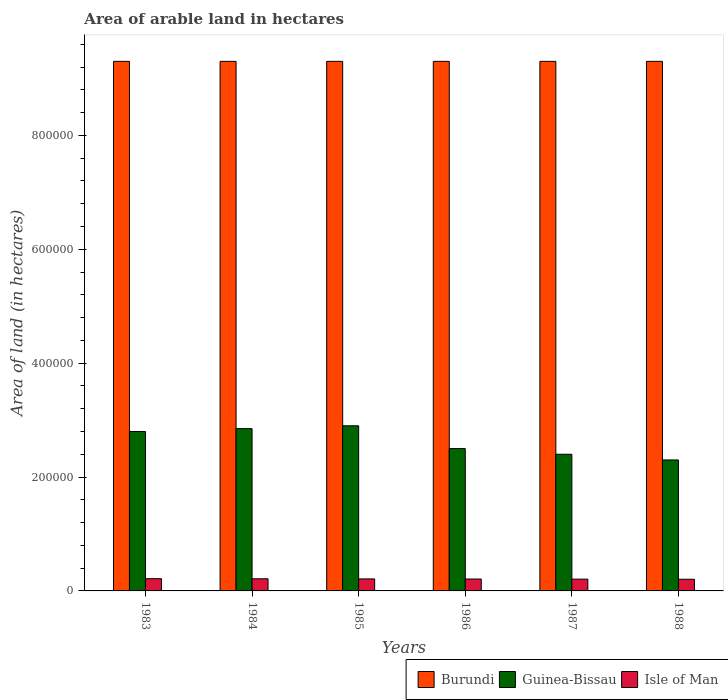How many groups of bars are there?
Provide a short and direct response. 6. Are the number of bars per tick equal to the number of legend labels?
Provide a short and direct response. Yes. Are the number of bars on each tick of the X-axis equal?
Provide a short and direct response. Yes. What is the label of the 1st group of bars from the left?
Provide a short and direct response. 1983. In how many cases, is the number of bars for a given year not equal to the number of legend labels?
Your answer should be compact. 0. What is the total arable land in Isle of Man in 1983?
Keep it short and to the point. 2.15e+04. Across all years, what is the maximum total arable land in Guinea-Bissau?
Give a very brief answer. 2.90e+05. Across all years, what is the minimum total arable land in Isle of Man?
Offer a terse response. 2.05e+04. In which year was the total arable land in Burundi maximum?
Your answer should be very brief. 1983. In which year was the total arable land in Guinea-Bissau minimum?
Provide a short and direct response. 1988. What is the total total arable land in Isle of Man in the graph?
Offer a very short reply. 1.26e+05. What is the difference between the total arable land in Guinea-Bissau in 1986 and that in 1987?
Provide a succinct answer. 10000. What is the difference between the total arable land in Guinea-Bissau in 1985 and the total arable land in Burundi in 1984?
Give a very brief answer. -6.40e+05. What is the average total arable land in Burundi per year?
Ensure brevity in your answer.  9.30e+05. In the year 1988, what is the difference between the total arable land in Isle of Man and total arable land in Guinea-Bissau?
Provide a succinct answer. -2.10e+05. What is the ratio of the total arable land in Guinea-Bissau in 1984 to that in 1986?
Ensure brevity in your answer.  1.14. Is the total arable land in Guinea-Bissau in 1983 less than that in 1984?
Your response must be concise. Yes. What is the difference between the highest and the second highest total arable land in Isle of Man?
Offer a terse response. 200. What is the difference between the highest and the lowest total arable land in Guinea-Bissau?
Provide a short and direct response. 6.00e+04. What does the 3rd bar from the left in 1983 represents?
Offer a very short reply. Isle of Man. What does the 1st bar from the right in 1983 represents?
Keep it short and to the point. Isle of Man. How many bars are there?
Make the answer very short. 18. Does the graph contain grids?
Keep it short and to the point. No. Where does the legend appear in the graph?
Make the answer very short. Bottom right. How many legend labels are there?
Ensure brevity in your answer.  3. How are the legend labels stacked?
Give a very brief answer. Horizontal. What is the title of the graph?
Ensure brevity in your answer.  Area of arable land in hectares. Does "Puerto Rico" appear as one of the legend labels in the graph?
Offer a very short reply. No. What is the label or title of the Y-axis?
Your answer should be very brief. Area of land (in hectares). What is the Area of land (in hectares) of Burundi in 1983?
Keep it short and to the point. 9.30e+05. What is the Area of land (in hectares) of Isle of Man in 1983?
Give a very brief answer. 2.15e+04. What is the Area of land (in hectares) in Burundi in 1984?
Make the answer very short. 9.30e+05. What is the Area of land (in hectares) of Guinea-Bissau in 1984?
Your answer should be very brief. 2.85e+05. What is the Area of land (in hectares) in Isle of Man in 1984?
Give a very brief answer. 2.13e+04. What is the Area of land (in hectares) in Burundi in 1985?
Ensure brevity in your answer.  9.30e+05. What is the Area of land (in hectares) in Isle of Man in 1985?
Ensure brevity in your answer.  2.11e+04. What is the Area of land (in hectares) in Burundi in 1986?
Offer a terse response. 9.30e+05. What is the Area of land (in hectares) of Guinea-Bissau in 1986?
Ensure brevity in your answer.  2.50e+05. What is the Area of land (in hectares) in Isle of Man in 1986?
Provide a succinct answer. 2.09e+04. What is the Area of land (in hectares) of Burundi in 1987?
Your response must be concise. 9.30e+05. What is the Area of land (in hectares) of Isle of Man in 1987?
Provide a succinct answer. 2.07e+04. What is the Area of land (in hectares) in Burundi in 1988?
Your answer should be compact. 9.30e+05. What is the Area of land (in hectares) in Isle of Man in 1988?
Offer a very short reply. 2.05e+04. Across all years, what is the maximum Area of land (in hectares) in Burundi?
Keep it short and to the point. 9.30e+05. Across all years, what is the maximum Area of land (in hectares) in Isle of Man?
Ensure brevity in your answer.  2.15e+04. Across all years, what is the minimum Area of land (in hectares) of Burundi?
Your answer should be compact. 9.30e+05. Across all years, what is the minimum Area of land (in hectares) of Isle of Man?
Provide a short and direct response. 2.05e+04. What is the total Area of land (in hectares) in Burundi in the graph?
Provide a succinct answer. 5.58e+06. What is the total Area of land (in hectares) in Guinea-Bissau in the graph?
Offer a very short reply. 1.58e+06. What is the total Area of land (in hectares) in Isle of Man in the graph?
Keep it short and to the point. 1.26e+05. What is the difference between the Area of land (in hectares) in Burundi in 1983 and that in 1984?
Give a very brief answer. 0. What is the difference between the Area of land (in hectares) of Guinea-Bissau in 1983 and that in 1984?
Provide a succinct answer. -5000. What is the difference between the Area of land (in hectares) in Isle of Man in 1983 and that in 1984?
Provide a succinct answer. 200. What is the difference between the Area of land (in hectares) of Burundi in 1983 and that in 1985?
Your response must be concise. 0. What is the difference between the Area of land (in hectares) of Isle of Man in 1983 and that in 1985?
Make the answer very short. 400. What is the difference between the Area of land (in hectares) in Burundi in 1983 and that in 1986?
Offer a terse response. 0. What is the difference between the Area of land (in hectares) of Guinea-Bissau in 1983 and that in 1986?
Offer a very short reply. 3.00e+04. What is the difference between the Area of land (in hectares) in Isle of Man in 1983 and that in 1986?
Provide a succinct answer. 600. What is the difference between the Area of land (in hectares) in Guinea-Bissau in 1983 and that in 1987?
Give a very brief answer. 4.00e+04. What is the difference between the Area of land (in hectares) in Isle of Man in 1983 and that in 1987?
Ensure brevity in your answer.  800. What is the difference between the Area of land (in hectares) of Guinea-Bissau in 1983 and that in 1988?
Keep it short and to the point. 5.00e+04. What is the difference between the Area of land (in hectares) in Guinea-Bissau in 1984 and that in 1985?
Your answer should be compact. -5000. What is the difference between the Area of land (in hectares) of Burundi in 1984 and that in 1986?
Your response must be concise. 0. What is the difference between the Area of land (in hectares) of Guinea-Bissau in 1984 and that in 1986?
Make the answer very short. 3.50e+04. What is the difference between the Area of land (in hectares) in Guinea-Bissau in 1984 and that in 1987?
Your answer should be compact. 4.50e+04. What is the difference between the Area of land (in hectares) in Isle of Man in 1984 and that in 1987?
Provide a succinct answer. 600. What is the difference between the Area of land (in hectares) of Guinea-Bissau in 1984 and that in 1988?
Your answer should be very brief. 5.50e+04. What is the difference between the Area of land (in hectares) in Isle of Man in 1984 and that in 1988?
Make the answer very short. 800. What is the difference between the Area of land (in hectares) of Burundi in 1985 and that in 1986?
Give a very brief answer. 0. What is the difference between the Area of land (in hectares) of Guinea-Bissau in 1985 and that in 1986?
Ensure brevity in your answer.  4.00e+04. What is the difference between the Area of land (in hectares) in Isle of Man in 1985 and that in 1986?
Your response must be concise. 200. What is the difference between the Area of land (in hectares) of Guinea-Bissau in 1985 and that in 1988?
Provide a succinct answer. 6.00e+04. What is the difference between the Area of land (in hectares) of Isle of Man in 1985 and that in 1988?
Your answer should be compact. 600. What is the difference between the Area of land (in hectares) in Burundi in 1986 and that in 1987?
Your answer should be compact. 0. What is the difference between the Area of land (in hectares) of Isle of Man in 1986 and that in 1987?
Offer a very short reply. 200. What is the difference between the Area of land (in hectares) of Burundi in 1986 and that in 1988?
Keep it short and to the point. 0. What is the difference between the Area of land (in hectares) of Isle of Man in 1986 and that in 1988?
Provide a short and direct response. 400. What is the difference between the Area of land (in hectares) of Burundi in 1983 and the Area of land (in hectares) of Guinea-Bissau in 1984?
Provide a succinct answer. 6.45e+05. What is the difference between the Area of land (in hectares) of Burundi in 1983 and the Area of land (in hectares) of Isle of Man in 1984?
Your answer should be very brief. 9.09e+05. What is the difference between the Area of land (in hectares) of Guinea-Bissau in 1983 and the Area of land (in hectares) of Isle of Man in 1984?
Make the answer very short. 2.59e+05. What is the difference between the Area of land (in hectares) of Burundi in 1983 and the Area of land (in hectares) of Guinea-Bissau in 1985?
Offer a terse response. 6.40e+05. What is the difference between the Area of land (in hectares) of Burundi in 1983 and the Area of land (in hectares) of Isle of Man in 1985?
Keep it short and to the point. 9.09e+05. What is the difference between the Area of land (in hectares) of Guinea-Bissau in 1983 and the Area of land (in hectares) of Isle of Man in 1985?
Provide a succinct answer. 2.59e+05. What is the difference between the Area of land (in hectares) of Burundi in 1983 and the Area of land (in hectares) of Guinea-Bissau in 1986?
Offer a terse response. 6.80e+05. What is the difference between the Area of land (in hectares) in Burundi in 1983 and the Area of land (in hectares) in Isle of Man in 1986?
Ensure brevity in your answer.  9.09e+05. What is the difference between the Area of land (in hectares) of Guinea-Bissau in 1983 and the Area of land (in hectares) of Isle of Man in 1986?
Provide a succinct answer. 2.59e+05. What is the difference between the Area of land (in hectares) of Burundi in 1983 and the Area of land (in hectares) of Guinea-Bissau in 1987?
Your response must be concise. 6.90e+05. What is the difference between the Area of land (in hectares) of Burundi in 1983 and the Area of land (in hectares) of Isle of Man in 1987?
Ensure brevity in your answer.  9.09e+05. What is the difference between the Area of land (in hectares) of Guinea-Bissau in 1983 and the Area of land (in hectares) of Isle of Man in 1987?
Keep it short and to the point. 2.59e+05. What is the difference between the Area of land (in hectares) of Burundi in 1983 and the Area of land (in hectares) of Isle of Man in 1988?
Offer a terse response. 9.10e+05. What is the difference between the Area of land (in hectares) in Guinea-Bissau in 1983 and the Area of land (in hectares) in Isle of Man in 1988?
Your answer should be compact. 2.60e+05. What is the difference between the Area of land (in hectares) of Burundi in 1984 and the Area of land (in hectares) of Guinea-Bissau in 1985?
Offer a terse response. 6.40e+05. What is the difference between the Area of land (in hectares) of Burundi in 1984 and the Area of land (in hectares) of Isle of Man in 1985?
Keep it short and to the point. 9.09e+05. What is the difference between the Area of land (in hectares) of Guinea-Bissau in 1984 and the Area of land (in hectares) of Isle of Man in 1985?
Ensure brevity in your answer.  2.64e+05. What is the difference between the Area of land (in hectares) of Burundi in 1984 and the Area of land (in hectares) of Guinea-Bissau in 1986?
Keep it short and to the point. 6.80e+05. What is the difference between the Area of land (in hectares) of Burundi in 1984 and the Area of land (in hectares) of Isle of Man in 1986?
Your answer should be very brief. 9.09e+05. What is the difference between the Area of land (in hectares) of Guinea-Bissau in 1984 and the Area of land (in hectares) of Isle of Man in 1986?
Provide a short and direct response. 2.64e+05. What is the difference between the Area of land (in hectares) of Burundi in 1984 and the Area of land (in hectares) of Guinea-Bissau in 1987?
Provide a short and direct response. 6.90e+05. What is the difference between the Area of land (in hectares) in Burundi in 1984 and the Area of land (in hectares) in Isle of Man in 1987?
Keep it short and to the point. 9.09e+05. What is the difference between the Area of land (in hectares) of Guinea-Bissau in 1984 and the Area of land (in hectares) of Isle of Man in 1987?
Offer a terse response. 2.64e+05. What is the difference between the Area of land (in hectares) of Burundi in 1984 and the Area of land (in hectares) of Guinea-Bissau in 1988?
Your answer should be very brief. 7.00e+05. What is the difference between the Area of land (in hectares) of Burundi in 1984 and the Area of land (in hectares) of Isle of Man in 1988?
Your answer should be compact. 9.10e+05. What is the difference between the Area of land (in hectares) of Guinea-Bissau in 1984 and the Area of land (in hectares) of Isle of Man in 1988?
Provide a succinct answer. 2.64e+05. What is the difference between the Area of land (in hectares) of Burundi in 1985 and the Area of land (in hectares) of Guinea-Bissau in 1986?
Offer a very short reply. 6.80e+05. What is the difference between the Area of land (in hectares) in Burundi in 1985 and the Area of land (in hectares) in Isle of Man in 1986?
Ensure brevity in your answer.  9.09e+05. What is the difference between the Area of land (in hectares) in Guinea-Bissau in 1985 and the Area of land (in hectares) in Isle of Man in 1986?
Offer a terse response. 2.69e+05. What is the difference between the Area of land (in hectares) of Burundi in 1985 and the Area of land (in hectares) of Guinea-Bissau in 1987?
Provide a succinct answer. 6.90e+05. What is the difference between the Area of land (in hectares) in Burundi in 1985 and the Area of land (in hectares) in Isle of Man in 1987?
Keep it short and to the point. 9.09e+05. What is the difference between the Area of land (in hectares) of Guinea-Bissau in 1985 and the Area of land (in hectares) of Isle of Man in 1987?
Ensure brevity in your answer.  2.69e+05. What is the difference between the Area of land (in hectares) of Burundi in 1985 and the Area of land (in hectares) of Guinea-Bissau in 1988?
Offer a very short reply. 7.00e+05. What is the difference between the Area of land (in hectares) of Burundi in 1985 and the Area of land (in hectares) of Isle of Man in 1988?
Provide a short and direct response. 9.10e+05. What is the difference between the Area of land (in hectares) in Guinea-Bissau in 1985 and the Area of land (in hectares) in Isle of Man in 1988?
Your answer should be very brief. 2.70e+05. What is the difference between the Area of land (in hectares) of Burundi in 1986 and the Area of land (in hectares) of Guinea-Bissau in 1987?
Give a very brief answer. 6.90e+05. What is the difference between the Area of land (in hectares) in Burundi in 1986 and the Area of land (in hectares) in Isle of Man in 1987?
Ensure brevity in your answer.  9.09e+05. What is the difference between the Area of land (in hectares) of Guinea-Bissau in 1986 and the Area of land (in hectares) of Isle of Man in 1987?
Your response must be concise. 2.29e+05. What is the difference between the Area of land (in hectares) in Burundi in 1986 and the Area of land (in hectares) in Guinea-Bissau in 1988?
Ensure brevity in your answer.  7.00e+05. What is the difference between the Area of land (in hectares) of Burundi in 1986 and the Area of land (in hectares) of Isle of Man in 1988?
Provide a short and direct response. 9.10e+05. What is the difference between the Area of land (in hectares) of Guinea-Bissau in 1986 and the Area of land (in hectares) of Isle of Man in 1988?
Your answer should be very brief. 2.30e+05. What is the difference between the Area of land (in hectares) in Burundi in 1987 and the Area of land (in hectares) in Guinea-Bissau in 1988?
Give a very brief answer. 7.00e+05. What is the difference between the Area of land (in hectares) in Burundi in 1987 and the Area of land (in hectares) in Isle of Man in 1988?
Keep it short and to the point. 9.10e+05. What is the difference between the Area of land (in hectares) in Guinea-Bissau in 1987 and the Area of land (in hectares) in Isle of Man in 1988?
Your answer should be very brief. 2.20e+05. What is the average Area of land (in hectares) of Burundi per year?
Keep it short and to the point. 9.30e+05. What is the average Area of land (in hectares) in Guinea-Bissau per year?
Give a very brief answer. 2.62e+05. What is the average Area of land (in hectares) in Isle of Man per year?
Your response must be concise. 2.10e+04. In the year 1983, what is the difference between the Area of land (in hectares) of Burundi and Area of land (in hectares) of Guinea-Bissau?
Make the answer very short. 6.50e+05. In the year 1983, what is the difference between the Area of land (in hectares) of Burundi and Area of land (in hectares) of Isle of Man?
Your answer should be compact. 9.08e+05. In the year 1983, what is the difference between the Area of land (in hectares) of Guinea-Bissau and Area of land (in hectares) of Isle of Man?
Offer a very short reply. 2.58e+05. In the year 1984, what is the difference between the Area of land (in hectares) in Burundi and Area of land (in hectares) in Guinea-Bissau?
Give a very brief answer. 6.45e+05. In the year 1984, what is the difference between the Area of land (in hectares) in Burundi and Area of land (in hectares) in Isle of Man?
Offer a very short reply. 9.09e+05. In the year 1984, what is the difference between the Area of land (in hectares) in Guinea-Bissau and Area of land (in hectares) in Isle of Man?
Give a very brief answer. 2.64e+05. In the year 1985, what is the difference between the Area of land (in hectares) in Burundi and Area of land (in hectares) in Guinea-Bissau?
Make the answer very short. 6.40e+05. In the year 1985, what is the difference between the Area of land (in hectares) of Burundi and Area of land (in hectares) of Isle of Man?
Provide a succinct answer. 9.09e+05. In the year 1985, what is the difference between the Area of land (in hectares) of Guinea-Bissau and Area of land (in hectares) of Isle of Man?
Provide a short and direct response. 2.69e+05. In the year 1986, what is the difference between the Area of land (in hectares) in Burundi and Area of land (in hectares) in Guinea-Bissau?
Offer a very short reply. 6.80e+05. In the year 1986, what is the difference between the Area of land (in hectares) of Burundi and Area of land (in hectares) of Isle of Man?
Offer a very short reply. 9.09e+05. In the year 1986, what is the difference between the Area of land (in hectares) of Guinea-Bissau and Area of land (in hectares) of Isle of Man?
Offer a terse response. 2.29e+05. In the year 1987, what is the difference between the Area of land (in hectares) of Burundi and Area of land (in hectares) of Guinea-Bissau?
Keep it short and to the point. 6.90e+05. In the year 1987, what is the difference between the Area of land (in hectares) in Burundi and Area of land (in hectares) in Isle of Man?
Keep it short and to the point. 9.09e+05. In the year 1987, what is the difference between the Area of land (in hectares) of Guinea-Bissau and Area of land (in hectares) of Isle of Man?
Your response must be concise. 2.19e+05. In the year 1988, what is the difference between the Area of land (in hectares) of Burundi and Area of land (in hectares) of Guinea-Bissau?
Keep it short and to the point. 7.00e+05. In the year 1988, what is the difference between the Area of land (in hectares) of Burundi and Area of land (in hectares) of Isle of Man?
Your response must be concise. 9.10e+05. In the year 1988, what is the difference between the Area of land (in hectares) of Guinea-Bissau and Area of land (in hectares) of Isle of Man?
Provide a succinct answer. 2.10e+05. What is the ratio of the Area of land (in hectares) in Guinea-Bissau in 1983 to that in 1984?
Your response must be concise. 0.98. What is the ratio of the Area of land (in hectares) in Isle of Man in 1983 to that in 1984?
Provide a short and direct response. 1.01. What is the ratio of the Area of land (in hectares) in Guinea-Bissau in 1983 to that in 1985?
Offer a terse response. 0.97. What is the ratio of the Area of land (in hectares) in Isle of Man in 1983 to that in 1985?
Ensure brevity in your answer.  1.02. What is the ratio of the Area of land (in hectares) in Burundi in 1983 to that in 1986?
Ensure brevity in your answer.  1. What is the ratio of the Area of land (in hectares) of Guinea-Bissau in 1983 to that in 1986?
Your answer should be compact. 1.12. What is the ratio of the Area of land (in hectares) in Isle of Man in 1983 to that in 1986?
Offer a terse response. 1.03. What is the ratio of the Area of land (in hectares) of Burundi in 1983 to that in 1987?
Offer a very short reply. 1. What is the ratio of the Area of land (in hectares) in Guinea-Bissau in 1983 to that in 1987?
Your answer should be very brief. 1.17. What is the ratio of the Area of land (in hectares) in Isle of Man in 1983 to that in 1987?
Give a very brief answer. 1.04. What is the ratio of the Area of land (in hectares) in Guinea-Bissau in 1983 to that in 1988?
Offer a very short reply. 1.22. What is the ratio of the Area of land (in hectares) in Isle of Man in 1983 to that in 1988?
Offer a very short reply. 1.05. What is the ratio of the Area of land (in hectares) in Burundi in 1984 to that in 1985?
Your response must be concise. 1. What is the ratio of the Area of land (in hectares) of Guinea-Bissau in 1984 to that in 1985?
Offer a terse response. 0.98. What is the ratio of the Area of land (in hectares) in Isle of Man in 1984 to that in 1985?
Your answer should be compact. 1.01. What is the ratio of the Area of land (in hectares) in Burundi in 1984 to that in 1986?
Ensure brevity in your answer.  1. What is the ratio of the Area of land (in hectares) in Guinea-Bissau in 1984 to that in 1986?
Provide a succinct answer. 1.14. What is the ratio of the Area of land (in hectares) in Isle of Man in 1984 to that in 1986?
Offer a very short reply. 1.02. What is the ratio of the Area of land (in hectares) of Burundi in 1984 to that in 1987?
Keep it short and to the point. 1. What is the ratio of the Area of land (in hectares) of Guinea-Bissau in 1984 to that in 1987?
Keep it short and to the point. 1.19. What is the ratio of the Area of land (in hectares) in Isle of Man in 1984 to that in 1987?
Ensure brevity in your answer.  1.03. What is the ratio of the Area of land (in hectares) in Guinea-Bissau in 1984 to that in 1988?
Provide a short and direct response. 1.24. What is the ratio of the Area of land (in hectares) of Isle of Man in 1984 to that in 1988?
Provide a short and direct response. 1.04. What is the ratio of the Area of land (in hectares) in Guinea-Bissau in 1985 to that in 1986?
Your response must be concise. 1.16. What is the ratio of the Area of land (in hectares) of Isle of Man in 1985 to that in 1986?
Provide a succinct answer. 1.01. What is the ratio of the Area of land (in hectares) in Guinea-Bissau in 1985 to that in 1987?
Your answer should be compact. 1.21. What is the ratio of the Area of land (in hectares) in Isle of Man in 1985 to that in 1987?
Ensure brevity in your answer.  1.02. What is the ratio of the Area of land (in hectares) of Burundi in 1985 to that in 1988?
Your answer should be very brief. 1. What is the ratio of the Area of land (in hectares) in Guinea-Bissau in 1985 to that in 1988?
Ensure brevity in your answer.  1.26. What is the ratio of the Area of land (in hectares) in Isle of Man in 1985 to that in 1988?
Your answer should be very brief. 1.03. What is the ratio of the Area of land (in hectares) of Guinea-Bissau in 1986 to that in 1987?
Ensure brevity in your answer.  1.04. What is the ratio of the Area of land (in hectares) of Isle of Man in 1986 to that in 1987?
Your answer should be compact. 1.01. What is the ratio of the Area of land (in hectares) of Guinea-Bissau in 1986 to that in 1988?
Provide a succinct answer. 1.09. What is the ratio of the Area of land (in hectares) of Isle of Man in 1986 to that in 1988?
Give a very brief answer. 1.02. What is the ratio of the Area of land (in hectares) of Guinea-Bissau in 1987 to that in 1988?
Provide a succinct answer. 1.04. What is the ratio of the Area of land (in hectares) in Isle of Man in 1987 to that in 1988?
Your answer should be compact. 1.01. What is the difference between the highest and the second highest Area of land (in hectares) of Burundi?
Keep it short and to the point. 0. What is the difference between the highest and the second highest Area of land (in hectares) of Guinea-Bissau?
Your answer should be compact. 5000. What is the difference between the highest and the lowest Area of land (in hectares) in Burundi?
Your answer should be compact. 0. What is the difference between the highest and the lowest Area of land (in hectares) in Guinea-Bissau?
Offer a terse response. 6.00e+04. 